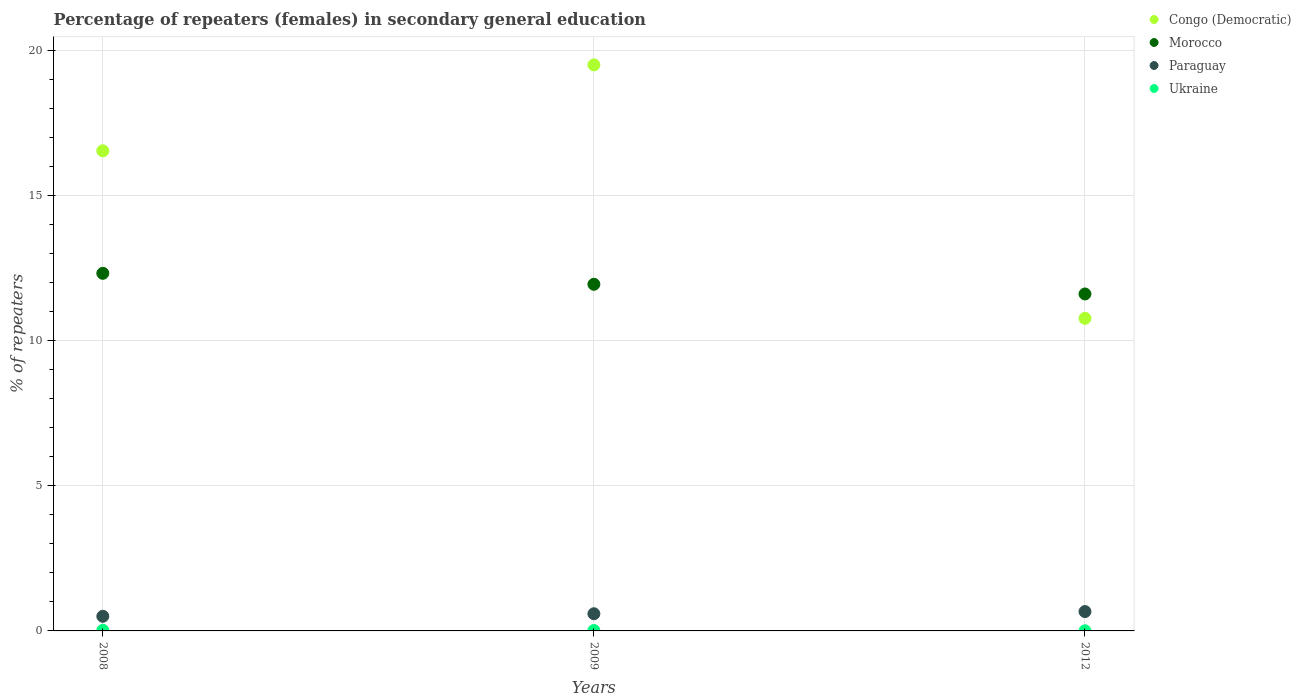How many different coloured dotlines are there?
Make the answer very short. 4. What is the percentage of female repeaters in Paraguay in 2009?
Keep it short and to the point. 0.59. Across all years, what is the maximum percentage of female repeaters in Paraguay?
Ensure brevity in your answer.  0.67. Across all years, what is the minimum percentage of female repeaters in Morocco?
Keep it short and to the point. 11.61. In which year was the percentage of female repeaters in Congo (Democratic) maximum?
Provide a succinct answer. 2009. In which year was the percentage of female repeaters in Paraguay minimum?
Your answer should be compact. 2008. What is the total percentage of female repeaters in Paraguay in the graph?
Keep it short and to the point. 1.76. What is the difference between the percentage of female repeaters in Congo (Democratic) in 2008 and that in 2009?
Make the answer very short. -2.96. What is the difference between the percentage of female repeaters in Congo (Democratic) in 2012 and the percentage of female repeaters in Ukraine in 2008?
Offer a very short reply. 10.75. What is the average percentage of female repeaters in Morocco per year?
Keep it short and to the point. 11.96. In the year 2009, what is the difference between the percentage of female repeaters in Morocco and percentage of female repeaters in Paraguay?
Provide a short and direct response. 11.36. In how many years, is the percentage of female repeaters in Ukraine greater than 14 %?
Make the answer very short. 0. What is the ratio of the percentage of female repeaters in Morocco in 2009 to that in 2012?
Give a very brief answer. 1.03. Is the percentage of female repeaters in Morocco in 2008 less than that in 2012?
Your response must be concise. No. What is the difference between the highest and the second highest percentage of female repeaters in Morocco?
Ensure brevity in your answer.  0.38. What is the difference between the highest and the lowest percentage of female repeaters in Morocco?
Keep it short and to the point. 0.71. Is it the case that in every year, the sum of the percentage of female repeaters in Ukraine and percentage of female repeaters in Paraguay  is greater than the sum of percentage of female repeaters in Morocco and percentage of female repeaters in Congo (Democratic)?
Give a very brief answer. No. How many dotlines are there?
Offer a very short reply. 4. How many years are there in the graph?
Provide a succinct answer. 3. What is the difference between two consecutive major ticks on the Y-axis?
Give a very brief answer. 5. Are the values on the major ticks of Y-axis written in scientific E-notation?
Offer a very short reply. No. Does the graph contain any zero values?
Offer a very short reply. No. Does the graph contain grids?
Offer a terse response. Yes. Where does the legend appear in the graph?
Keep it short and to the point. Top right. How many legend labels are there?
Offer a terse response. 4. What is the title of the graph?
Give a very brief answer. Percentage of repeaters (females) in secondary general education. What is the label or title of the X-axis?
Offer a very short reply. Years. What is the label or title of the Y-axis?
Provide a short and direct response. % of repeaters. What is the % of repeaters in Congo (Democratic) in 2008?
Make the answer very short. 16.55. What is the % of repeaters of Morocco in 2008?
Provide a succinct answer. 12.33. What is the % of repeaters of Paraguay in 2008?
Your answer should be very brief. 0.5. What is the % of repeaters of Ukraine in 2008?
Make the answer very short. 0.02. What is the % of repeaters in Congo (Democratic) in 2009?
Your response must be concise. 19.51. What is the % of repeaters of Morocco in 2009?
Provide a succinct answer. 11.95. What is the % of repeaters in Paraguay in 2009?
Offer a terse response. 0.59. What is the % of repeaters of Ukraine in 2009?
Offer a terse response. 0.01. What is the % of repeaters of Congo (Democratic) in 2012?
Give a very brief answer. 10.77. What is the % of repeaters in Morocco in 2012?
Ensure brevity in your answer.  11.61. What is the % of repeaters of Paraguay in 2012?
Your answer should be very brief. 0.67. What is the % of repeaters in Ukraine in 2012?
Keep it short and to the point. 0. Across all years, what is the maximum % of repeaters in Congo (Democratic)?
Your answer should be compact. 19.51. Across all years, what is the maximum % of repeaters of Morocco?
Your response must be concise. 12.33. Across all years, what is the maximum % of repeaters in Paraguay?
Offer a very short reply. 0.67. Across all years, what is the maximum % of repeaters of Ukraine?
Make the answer very short. 0.02. Across all years, what is the minimum % of repeaters in Congo (Democratic)?
Provide a short and direct response. 10.77. Across all years, what is the minimum % of repeaters in Morocco?
Give a very brief answer. 11.61. Across all years, what is the minimum % of repeaters in Paraguay?
Your answer should be very brief. 0.5. Across all years, what is the minimum % of repeaters of Ukraine?
Your answer should be compact. 0. What is the total % of repeaters of Congo (Democratic) in the graph?
Provide a short and direct response. 46.83. What is the total % of repeaters of Morocco in the graph?
Offer a terse response. 35.89. What is the total % of repeaters in Paraguay in the graph?
Your response must be concise. 1.76. What is the total % of repeaters in Ukraine in the graph?
Keep it short and to the point. 0.04. What is the difference between the % of repeaters in Congo (Democratic) in 2008 and that in 2009?
Your answer should be very brief. -2.96. What is the difference between the % of repeaters in Morocco in 2008 and that in 2009?
Provide a short and direct response. 0.38. What is the difference between the % of repeaters of Paraguay in 2008 and that in 2009?
Give a very brief answer. -0.09. What is the difference between the % of repeaters of Ukraine in 2008 and that in 2009?
Keep it short and to the point. 0.01. What is the difference between the % of repeaters in Congo (Democratic) in 2008 and that in 2012?
Provide a short and direct response. 5.77. What is the difference between the % of repeaters of Morocco in 2008 and that in 2012?
Ensure brevity in your answer.  0.71. What is the difference between the % of repeaters of Paraguay in 2008 and that in 2012?
Your response must be concise. -0.16. What is the difference between the % of repeaters in Ukraine in 2008 and that in 2012?
Give a very brief answer. 0.02. What is the difference between the % of repeaters in Congo (Democratic) in 2009 and that in 2012?
Your answer should be compact. 8.74. What is the difference between the % of repeaters in Morocco in 2009 and that in 2012?
Make the answer very short. 0.33. What is the difference between the % of repeaters in Paraguay in 2009 and that in 2012?
Make the answer very short. -0.07. What is the difference between the % of repeaters in Ukraine in 2009 and that in 2012?
Keep it short and to the point. 0.01. What is the difference between the % of repeaters of Congo (Democratic) in 2008 and the % of repeaters of Morocco in 2009?
Offer a terse response. 4.6. What is the difference between the % of repeaters in Congo (Democratic) in 2008 and the % of repeaters in Paraguay in 2009?
Provide a short and direct response. 15.96. What is the difference between the % of repeaters of Congo (Democratic) in 2008 and the % of repeaters of Ukraine in 2009?
Ensure brevity in your answer.  16.53. What is the difference between the % of repeaters of Morocco in 2008 and the % of repeaters of Paraguay in 2009?
Your response must be concise. 11.73. What is the difference between the % of repeaters in Morocco in 2008 and the % of repeaters in Ukraine in 2009?
Offer a terse response. 12.31. What is the difference between the % of repeaters of Paraguay in 2008 and the % of repeaters of Ukraine in 2009?
Your answer should be very brief. 0.49. What is the difference between the % of repeaters in Congo (Democratic) in 2008 and the % of repeaters in Morocco in 2012?
Offer a very short reply. 4.93. What is the difference between the % of repeaters in Congo (Democratic) in 2008 and the % of repeaters in Paraguay in 2012?
Offer a very short reply. 15.88. What is the difference between the % of repeaters in Congo (Democratic) in 2008 and the % of repeaters in Ukraine in 2012?
Make the answer very short. 16.54. What is the difference between the % of repeaters of Morocco in 2008 and the % of repeaters of Paraguay in 2012?
Ensure brevity in your answer.  11.66. What is the difference between the % of repeaters in Morocco in 2008 and the % of repeaters in Ukraine in 2012?
Your response must be concise. 12.32. What is the difference between the % of repeaters in Paraguay in 2008 and the % of repeaters in Ukraine in 2012?
Keep it short and to the point. 0.5. What is the difference between the % of repeaters in Congo (Democratic) in 2009 and the % of repeaters in Morocco in 2012?
Keep it short and to the point. 7.9. What is the difference between the % of repeaters in Congo (Democratic) in 2009 and the % of repeaters in Paraguay in 2012?
Provide a succinct answer. 18.84. What is the difference between the % of repeaters in Congo (Democratic) in 2009 and the % of repeaters in Ukraine in 2012?
Give a very brief answer. 19.51. What is the difference between the % of repeaters in Morocco in 2009 and the % of repeaters in Paraguay in 2012?
Your answer should be very brief. 11.28. What is the difference between the % of repeaters in Morocco in 2009 and the % of repeaters in Ukraine in 2012?
Provide a succinct answer. 11.94. What is the difference between the % of repeaters in Paraguay in 2009 and the % of repeaters in Ukraine in 2012?
Offer a terse response. 0.59. What is the average % of repeaters of Congo (Democratic) per year?
Your answer should be compact. 15.61. What is the average % of repeaters of Morocco per year?
Your answer should be compact. 11.96. What is the average % of repeaters of Paraguay per year?
Ensure brevity in your answer.  0.59. What is the average % of repeaters of Ukraine per year?
Provide a succinct answer. 0.01. In the year 2008, what is the difference between the % of repeaters of Congo (Democratic) and % of repeaters of Morocco?
Your answer should be compact. 4.22. In the year 2008, what is the difference between the % of repeaters in Congo (Democratic) and % of repeaters in Paraguay?
Give a very brief answer. 16.04. In the year 2008, what is the difference between the % of repeaters in Congo (Democratic) and % of repeaters in Ukraine?
Your answer should be very brief. 16.53. In the year 2008, what is the difference between the % of repeaters of Morocco and % of repeaters of Paraguay?
Provide a succinct answer. 11.82. In the year 2008, what is the difference between the % of repeaters in Morocco and % of repeaters in Ukraine?
Make the answer very short. 12.3. In the year 2008, what is the difference between the % of repeaters in Paraguay and % of repeaters in Ukraine?
Your response must be concise. 0.48. In the year 2009, what is the difference between the % of repeaters of Congo (Democratic) and % of repeaters of Morocco?
Your response must be concise. 7.56. In the year 2009, what is the difference between the % of repeaters in Congo (Democratic) and % of repeaters in Paraguay?
Ensure brevity in your answer.  18.92. In the year 2009, what is the difference between the % of repeaters in Congo (Democratic) and % of repeaters in Ukraine?
Your response must be concise. 19.5. In the year 2009, what is the difference between the % of repeaters of Morocco and % of repeaters of Paraguay?
Offer a very short reply. 11.36. In the year 2009, what is the difference between the % of repeaters of Morocco and % of repeaters of Ukraine?
Make the answer very short. 11.93. In the year 2009, what is the difference between the % of repeaters in Paraguay and % of repeaters in Ukraine?
Give a very brief answer. 0.58. In the year 2012, what is the difference between the % of repeaters in Congo (Democratic) and % of repeaters in Morocco?
Give a very brief answer. -0.84. In the year 2012, what is the difference between the % of repeaters in Congo (Democratic) and % of repeaters in Paraguay?
Your answer should be compact. 10.11. In the year 2012, what is the difference between the % of repeaters in Congo (Democratic) and % of repeaters in Ukraine?
Ensure brevity in your answer.  10.77. In the year 2012, what is the difference between the % of repeaters of Morocco and % of repeaters of Paraguay?
Offer a very short reply. 10.95. In the year 2012, what is the difference between the % of repeaters of Morocco and % of repeaters of Ukraine?
Offer a terse response. 11.61. In the year 2012, what is the difference between the % of repeaters of Paraguay and % of repeaters of Ukraine?
Your response must be concise. 0.66. What is the ratio of the % of repeaters of Congo (Democratic) in 2008 to that in 2009?
Your response must be concise. 0.85. What is the ratio of the % of repeaters in Morocco in 2008 to that in 2009?
Offer a terse response. 1.03. What is the ratio of the % of repeaters in Paraguay in 2008 to that in 2009?
Your answer should be compact. 0.85. What is the ratio of the % of repeaters of Ukraine in 2008 to that in 2009?
Provide a succinct answer. 1.55. What is the ratio of the % of repeaters in Congo (Democratic) in 2008 to that in 2012?
Provide a succinct answer. 1.54. What is the ratio of the % of repeaters of Morocco in 2008 to that in 2012?
Ensure brevity in your answer.  1.06. What is the ratio of the % of repeaters of Paraguay in 2008 to that in 2012?
Ensure brevity in your answer.  0.76. What is the ratio of the % of repeaters of Ukraine in 2008 to that in 2012?
Give a very brief answer. 4.54. What is the ratio of the % of repeaters in Congo (Democratic) in 2009 to that in 2012?
Your response must be concise. 1.81. What is the ratio of the % of repeaters in Morocco in 2009 to that in 2012?
Keep it short and to the point. 1.03. What is the ratio of the % of repeaters of Paraguay in 2009 to that in 2012?
Make the answer very short. 0.89. What is the ratio of the % of repeaters in Ukraine in 2009 to that in 2012?
Give a very brief answer. 2.93. What is the difference between the highest and the second highest % of repeaters of Congo (Democratic)?
Your response must be concise. 2.96. What is the difference between the highest and the second highest % of repeaters of Morocco?
Offer a terse response. 0.38. What is the difference between the highest and the second highest % of repeaters in Paraguay?
Your answer should be very brief. 0.07. What is the difference between the highest and the second highest % of repeaters in Ukraine?
Your response must be concise. 0.01. What is the difference between the highest and the lowest % of repeaters of Congo (Democratic)?
Make the answer very short. 8.74. What is the difference between the highest and the lowest % of repeaters in Morocco?
Your answer should be compact. 0.71. What is the difference between the highest and the lowest % of repeaters in Paraguay?
Keep it short and to the point. 0.16. What is the difference between the highest and the lowest % of repeaters in Ukraine?
Provide a short and direct response. 0.02. 